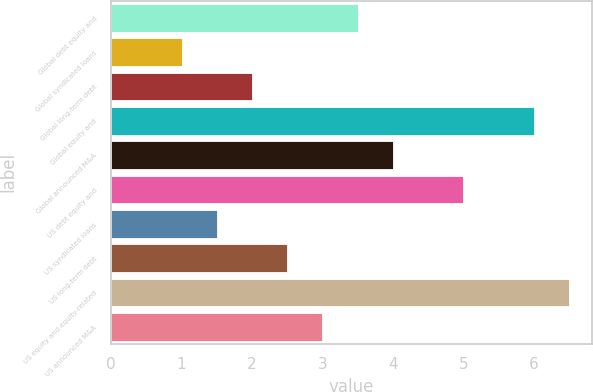Convert chart. <chart><loc_0><loc_0><loc_500><loc_500><bar_chart><fcel>Global debt equity and<fcel>Global syndicated loans<fcel>Global long-term debt<fcel>Global equity and<fcel>Global announced M&A<fcel>US debt equity and<fcel>US syndicated loans<fcel>US long-term debt<fcel>US equity and equity-related<fcel>US announced M&A<nl><fcel>3.5<fcel>1<fcel>2<fcel>6<fcel>4<fcel>5<fcel>1.5<fcel>2.5<fcel>6.5<fcel>3<nl></chart> 